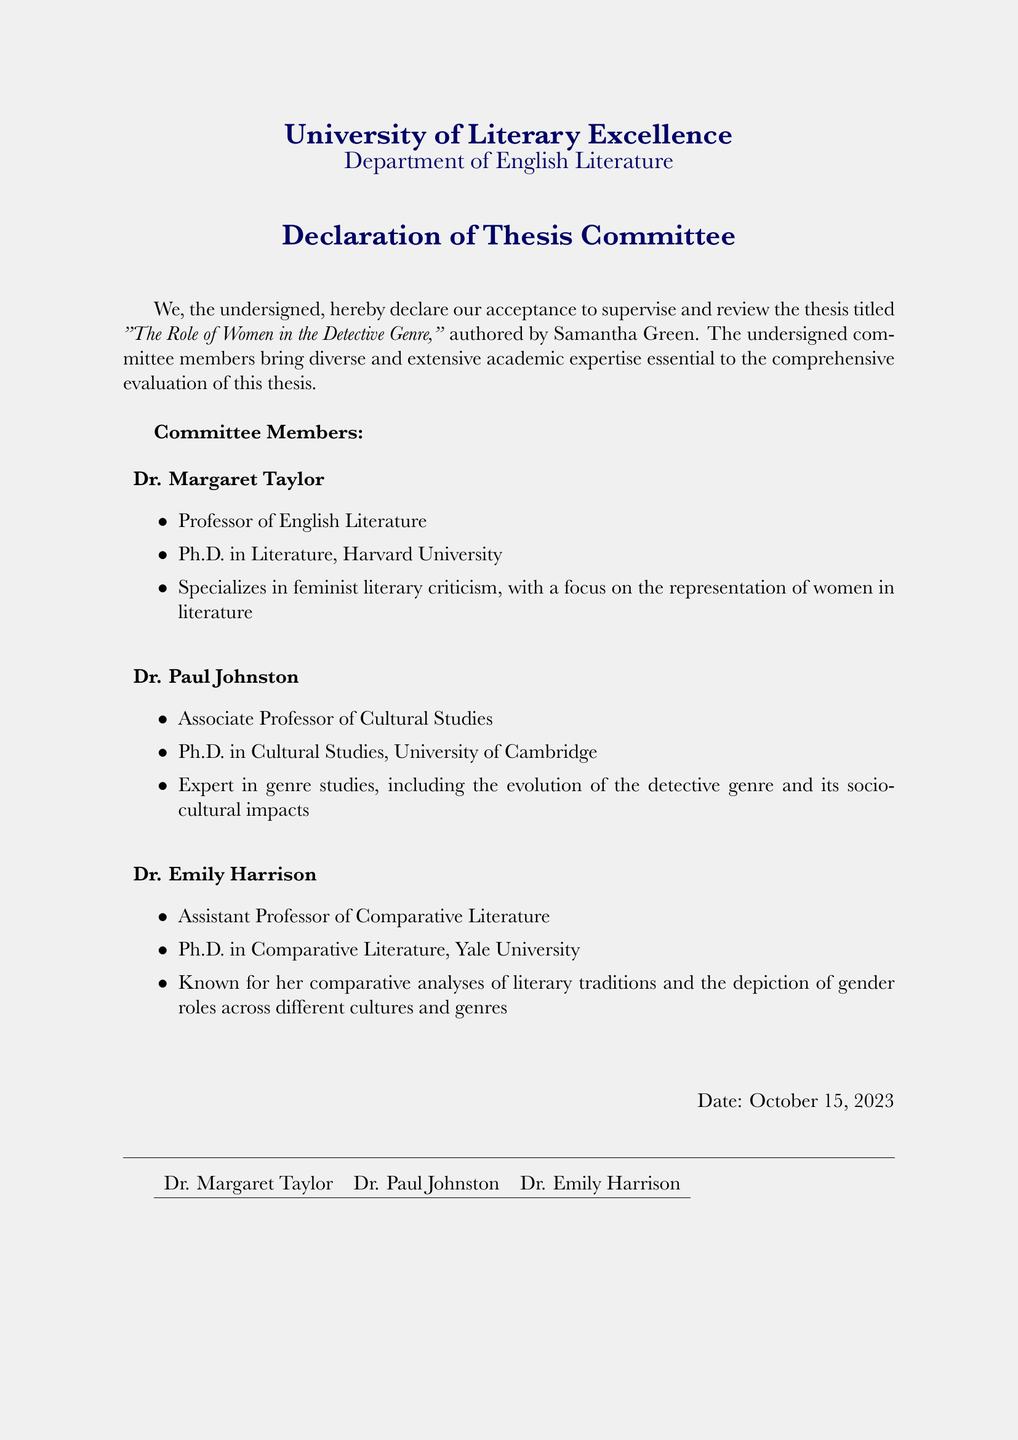What is the title of the thesis? The title of the thesis is explicitly mentioned in the document as "The Role of Women in the Detective Genre."
Answer: The Role of Women in the Detective Genre Who is the author of the thesis? The document states that the thesis is authored by Samantha Green.
Answer: Samantha Green How many committee members are listed? The document includes three committee members.
Answer: 3 What is Dr. Margaret Taylor's area of specialization? The document specifies that Dr. Margaret Taylor specializes in feminist literary criticism.
Answer: feminist literary criticism What institution did Dr. Paul Johnston receive his Ph.D. from? The document indicates that Dr. Paul Johnston obtained his Ph.D. from the University of Cambridge.
Answer: University of Cambridge What is the date of the declaration? The document clearly states the date of the declaration as October 15, 2023.
Answer: October 15, 2023 Which committee member is an Assistant Professor? The document identifies Dr. Emily Harrison as the Assistant Professor on the committee.
Answer: Dr. Emily Harrison Which member specializes in genre studies? According to the document, Dr. Paul Johnston is the member who specializes in genre studies.
Answer: Dr. Paul Johnston What is the purpose of this document? The document serves to express the committee's acceptance to supervise and review the thesis.
Answer: To supervise and review the thesis 